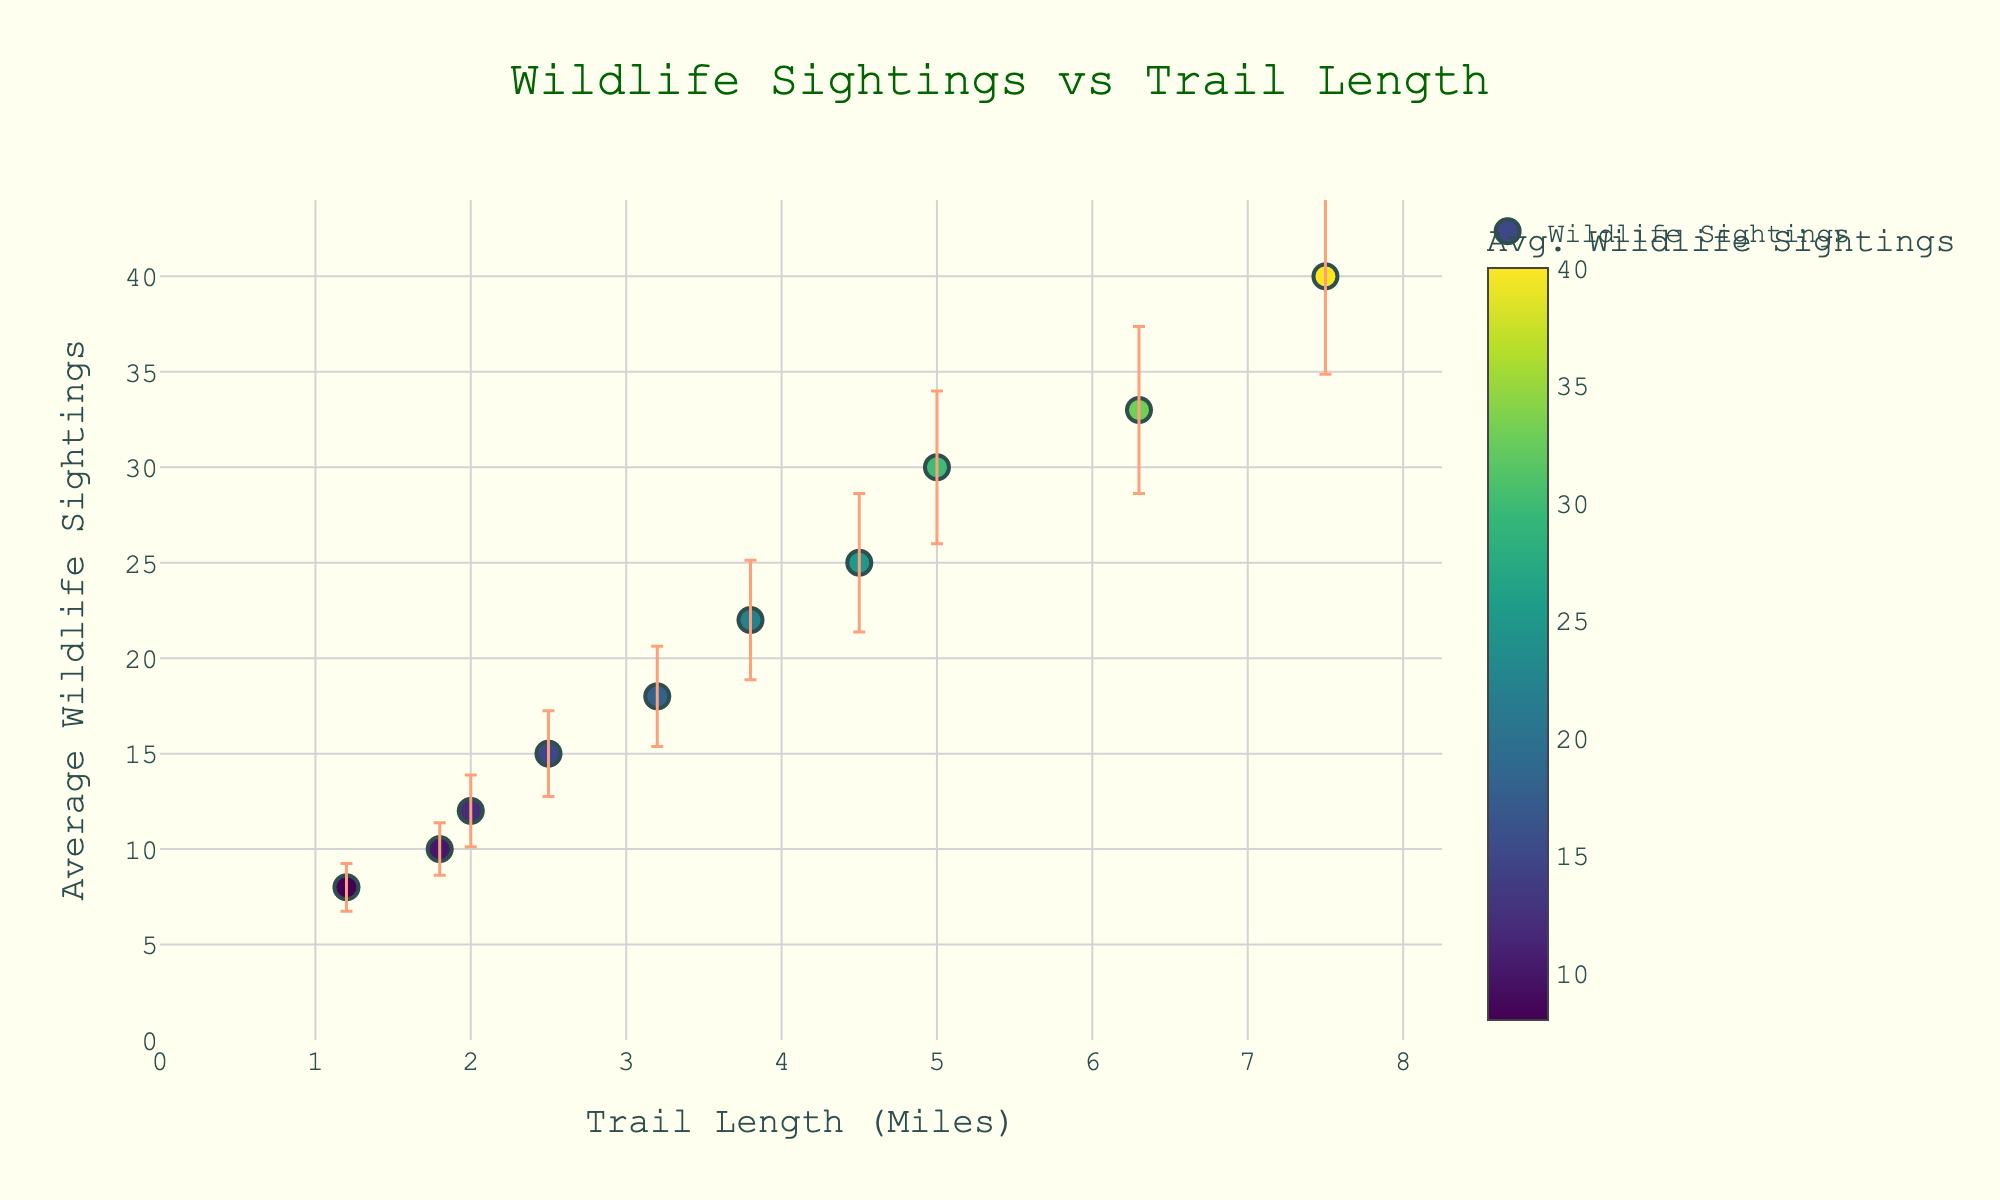What's the title of the plot? The title is at the top of the plot, centered and in a larger font size, which reads, "Wildlife Sightings vs Trail Length".
Answer: "Wildlife Sightings vs Trail Length" What's the y-axis labeled as? The label for the y-axis is shown vertically along the left side of the plot, which reads "Average Wildlife Sightings".
Answer: "Average Wildlife Sightings" How many data points are shown on the scatter plot? Each trail name is represented by a single point on the plot. Counting the points gives us a total of ten.
Answer: Ten Which trail has the highest average wildlife sightings? Look at the y-values of the points and locate the highest value, which is 40. Hovering over the point shows it corresponds to HawkRidgeTrail.
Answer: "HawkRidgeTrail" What is the average error bar value for RainbowFallsTrail? Hovering over the respective data point shows details including the error bars. The plot shows RainbowFallsTrail with an error bar value calculated by averaging its seasonal error bars: (1+2+1+1.5)/4 = 1.375.
Answer: 1.375 Which trail length has the smallest average error bar value? Find the points with the smallest error bar lines, then hover over them to see details. EvergreenLoop has the smallest error bars across seasons.
Answer: EvergreenLoop What's the relation between trail length and average wildlife sightings? Notice that as the x-values (trail lengths) increase, the y-values (average wildlife sightings) also generally increase, indicating a positive correlation.
Answer: Positive correlation What is the difference in average wildlife sightings between BlueBirdTrail and RiverbendTrail? Locate both points on the plot. BlueBirdTrail has 30 sightings and RiverbendTrail has 12. Subtract 12 from 30 to get the difference.
Answer: 18 How much does the error bar vary for SunnyRidgeTrail in summer? The plot's hover information shows "ErrorBar(Summer)" for SunnyRidgeTrail is 4. This indicates the variability in wildlife sightings during summer for this trail.
Answer: 4 Which trail has the longest length but is not the highest in average sightings? HawkRidgeTrail has the longest length at 7.5 miles but the highest sightings. The next longest is MeadowViewTrail at 6.3 miles, which is also not the highest.
Answer: MeadowViewTrail 